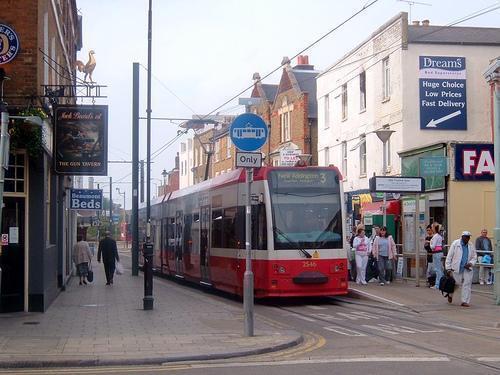In which location does this bus run?
Make your selection and explain in format: 'Answer: answer
Rationale: rationale.'
Options: Rural, city, suburbs, farm. Answer: city.
Rationale: Buses always run where there are the most people so it would be in an urban area. 